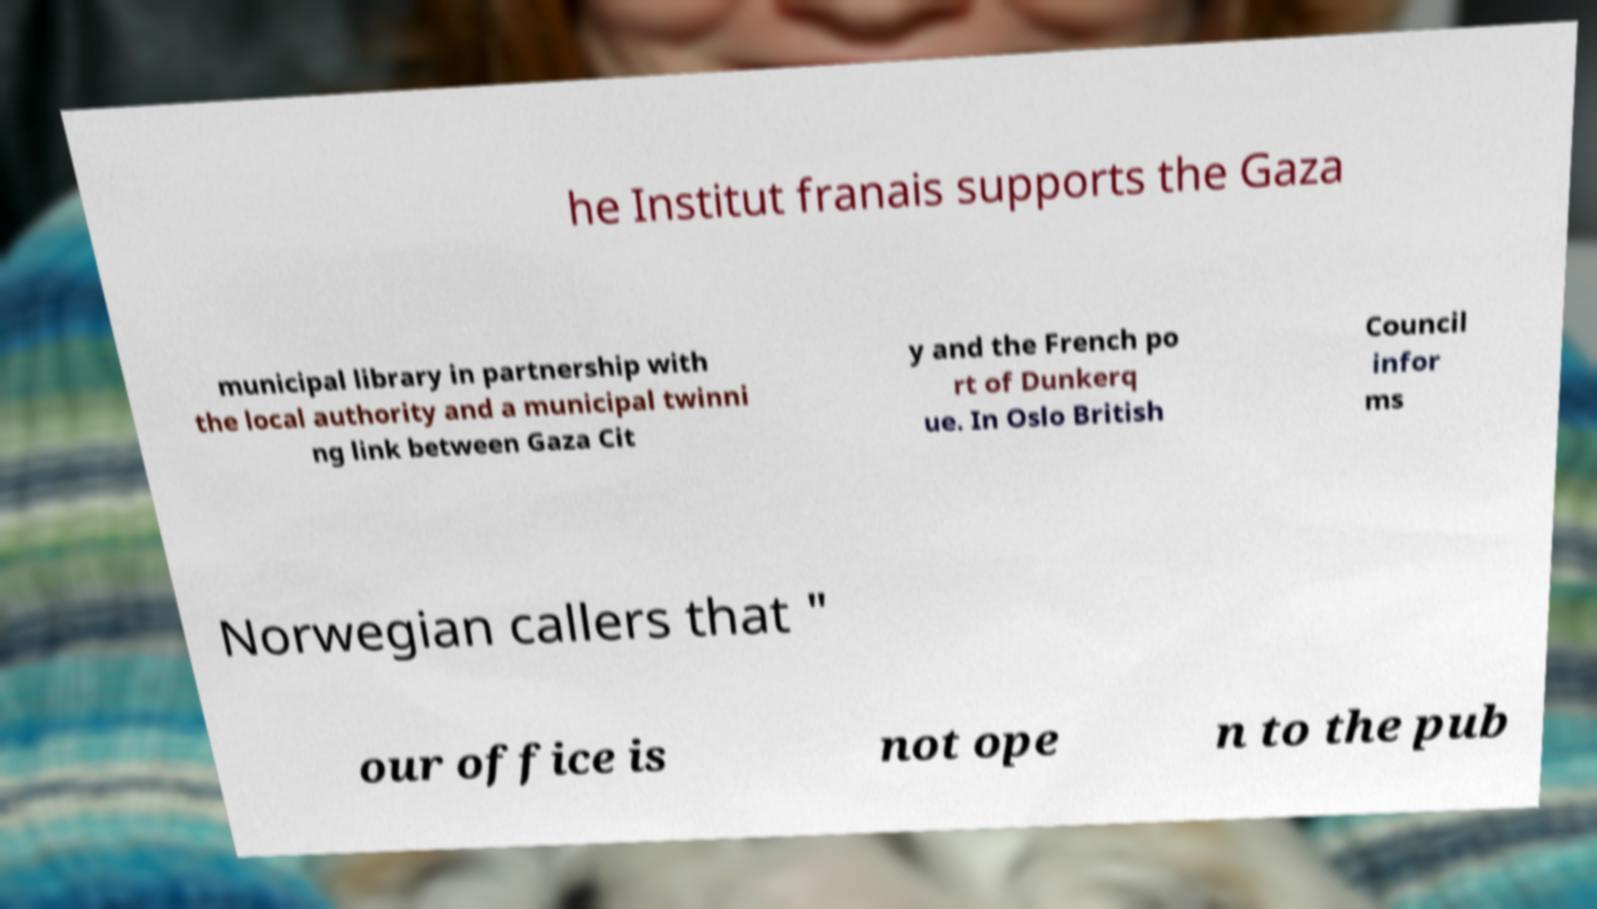Please identify and transcribe the text found in this image. he Institut franais supports the Gaza municipal library in partnership with the local authority and a municipal twinni ng link between Gaza Cit y and the French po rt of Dunkerq ue. In Oslo British Council infor ms Norwegian callers that " our office is not ope n to the pub 